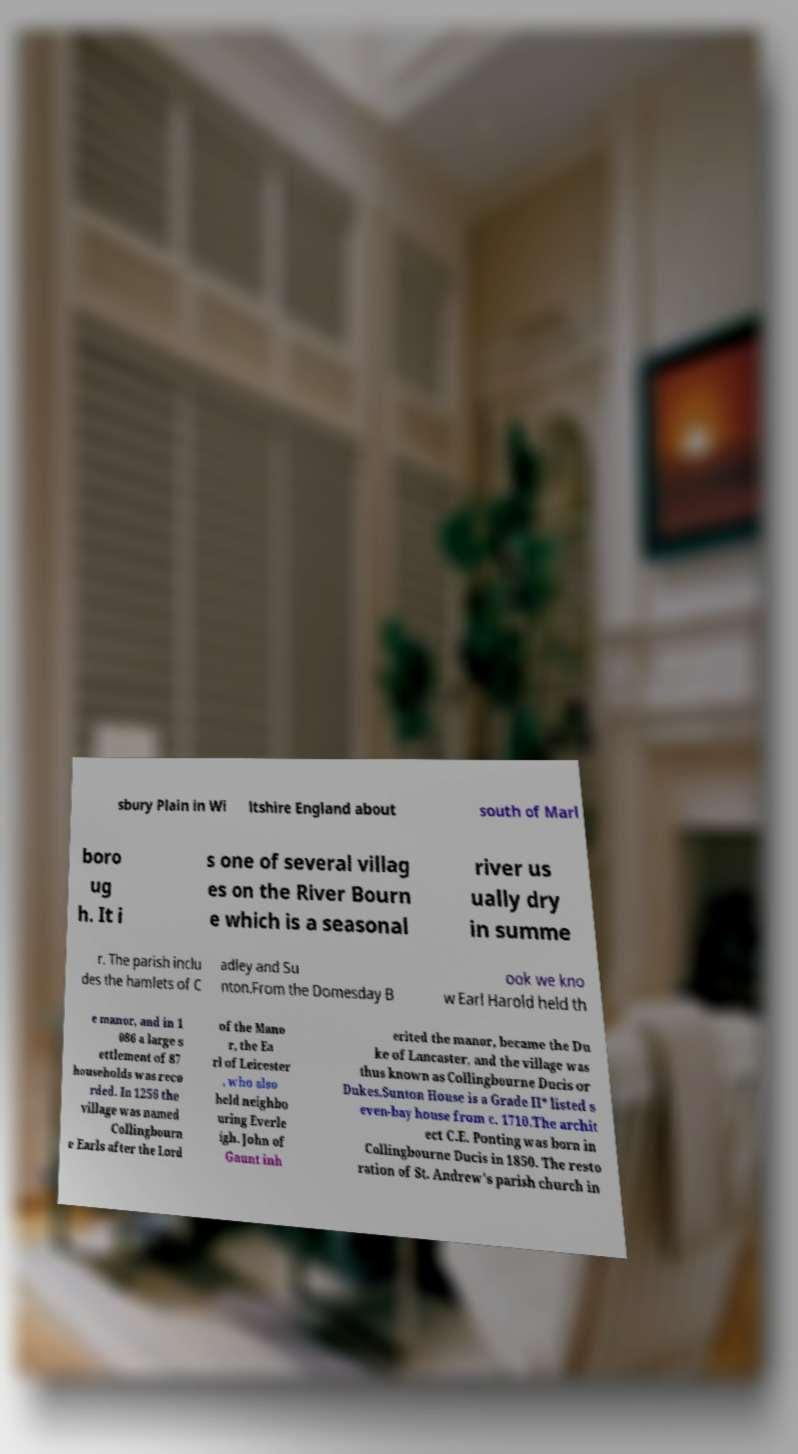Could you assist in decoding the text presented in this image and type it out clearly? sbury Plain in Wi ltshire England about south of Marl boro ug h. It i s one of several villag es on the River Bourn e which is a seasonal river us ually dry in summe r. The parish inclu des the hamlets of C adley and Su nton.From the Domesday B ook we kno w Earl Harold held th e manor, and in 1 086 a large s ettlement of 87 households was reco rded. In 1256 the village was named Collingbourn e Earls after the Lord of the Mano r, the Ea rl of Leicester , who also held neighbo uring Everle igh. John of Gaunt inh erited the manor, became the Du ke of Lancaster, and the village was thus known as Collingbourne Ducis or Dukes.Sunton House is a Grade II* listed s even-bay house from c. 1710.The archit ect C.E. Ponting was born in Collingbourne Ducis in 1850. The resto ration of St. Andrew's parish church in 